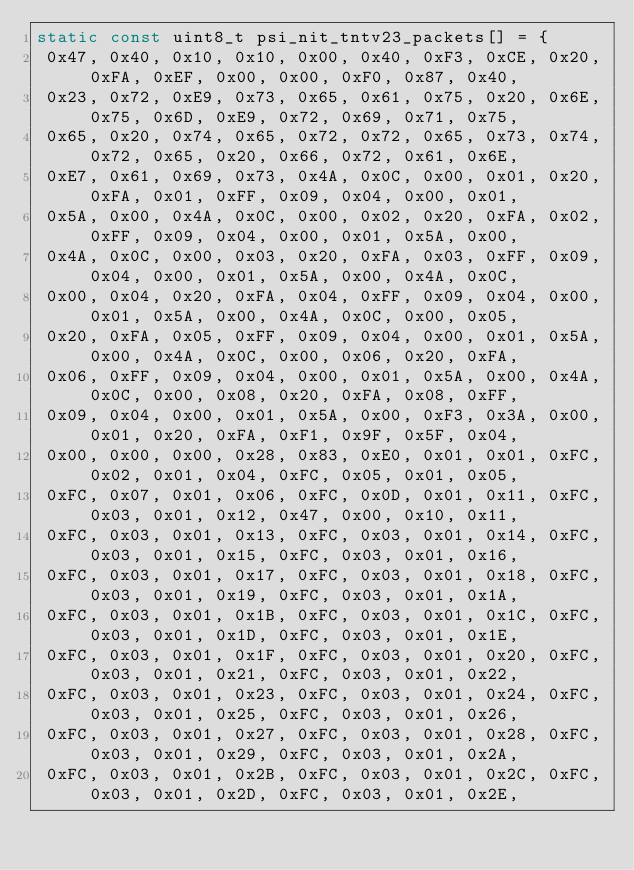<code> <loc_0><loc_0><loc_500><loc_500><_C_>static const uint8_t psi_nit_tntv23_packets[] = {
 0x47, 0x40, 0x10, 0x10, 0x00, 0x40, 0xF3, 0xCE, 0x20, 0xFA, 0xEF, 0x00, 0x00, 0xF0, 0x87, 0x40,
 0x23, 0x72, 0xE9, 0x73, 0x65, 0x61, 0x75, 0x20, 0x6E, 0x75, 0x6D, 0xE9, 0x72, 0x69, 0x71, 0x75,
 0x65, 0x20, 0x74, 0x65, 0x72, 0x72, 0x65, 0x73, 0x74, 0x72, 0x65, 0x20, 0x66, 0x72, 0x61, 0x6E,
 0xE7, 0x61, 0x69, 0x73, 0x4A, 0x0C, 0x00, 0x01, 0x20, 0xFA, 0x01, 0xFF, 0x09, 0x04, 0x00, 0x01,
 0x5A, 0x00, 0x4A, 0x0C, 0x00, 0x02, 0x20, 0xFA, 0x02, 0xFF, 0x09, 0x04, 0x00, 0x01, 0x5A, 0x00,
 0x4A, 0x0C, 0x00, 0x03, 0x20, 0xFA, 0x03, 0xFF, 0x09, 0x04, 0x00, 0x01, 0x5A, 0x00, 0x4A, 0x0C,
 0x00, 0x04, 0x20, 0xFA, 0x04, 0xFF, 0x09, 0x04, 0x00, 0x01, 0x5A, 0x00, 0x4A, 0x0C, 0x00, 0x05,
 0x20, 0xFA, 0x05, 0xFF, 0x09, 0x04, 0x00, 0x01, 0x5A, 0x00, 0x4A, 0x0C, 0x00, 0x06, 0x20, 0xFA,
 0x06, 0xFF, 0x09, 0x04, 0x00, 0x01, 0x5A, 0x00, 0x4A, 0x0C, 0x00, 0x08, 0x20, 0xFA, 0x08, 0xFF,
 0x09, 0x04, 0x00, 0x01, 0x5A, 0x00, 0xF3, 0x3A, 0x00, 0x01, 0x20, 0xFA, 0xF1, 0x9F, 0x5F, 0x04,
 0x00, 0x00, 0x00, 0x28, 0x83, 0xE0, 0x01, 0x01, 0xFC, 0x02, 0x01, 0x04, 0xFC, 0x05, 0x01, 0x05,
 0xFC, 0x07, 0x01, 0x06, 0xFC, 0x0D, 0x01, 0x11, 0xFC, 0x03, 0x01, 0x12, 0x47, 0x00, 0x10, 0x11,
 0xFC, 0x03, 0x01, 0x13, 0xFC, 0x03, 0x01, 0x14, 0xFC, 0x03, 0x01, 0x15, 0xFC, 0x03, 0x01, 0x16,
 0xFC, 0x03, 0x01, 0x17, 0xFC, 0x03, 0x01, 0x18, 0xFC, 0x03, 0x01, 0x19, 0xFC, 0x03, 0x01, 0x1A,
 0xFC, 0x03, 0x01, 0x1B, 0xFC, 0x03, 0x01, 0x1C, 0xFC, 0x03, 0x01, 0x1D, 0xFC, 0x03, 0x01, 0x1E,
 0xFC, 0x03, 0x01, 0x1F, 0xFC, 0x03, 0x01, 0x20, 0xFC, 0x03, 0x01, 0x21, 0xFC, 0x03, 0x01, 0x22,
 0xFC, 0x03, 0x01, 0x23, 0xFC, 0x03, 0x01, 0x24, 0xFC, 0x03, 0x01, 0x25, 0xFC, 0x03, 0x01, 0x26,
 0xFC, 0x03, 0x01, 0x27, 0xFC, 0x03, 0x01, 0x28, 0xFC, 0x03, 0x01, 0x29, 0xFC, 0x03, 0x01, 0x2A,
 0xFC, 0x03, 0x01, 0x2B, 0xFC, 0x03, 0x01, 0x2C, 0xFC, 0x03, 0x01, 0x2D, 0xFC, 0x03, 0x01, 0x2E,</code> 